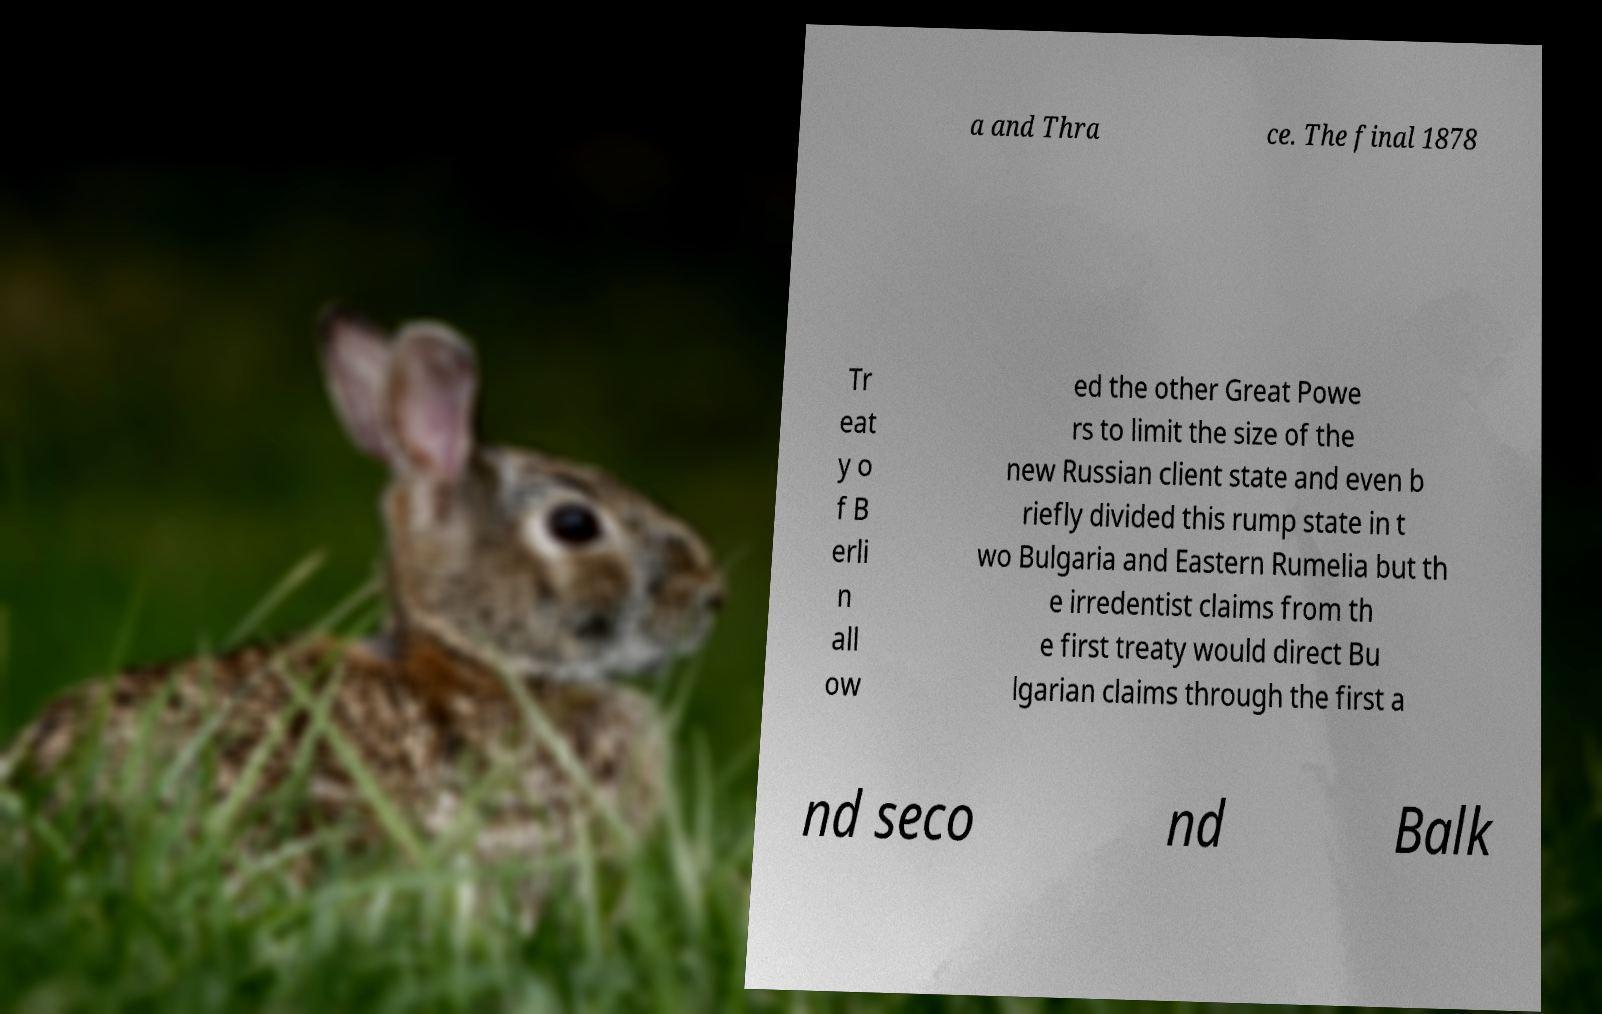Please identify and transcribe the text found in this image. a and Thra ce. The final 1878 Tr eat y o f B erli n all ow ed the other Great Powe rs to limit the size of the new Russian client state and even b riefly divided this rump state in t wo Bulgaria and Eastern Rumelia but th e irredentist claims from th e first treaty would direct Bu lgarian claims through the first a nd seco nd Balk 